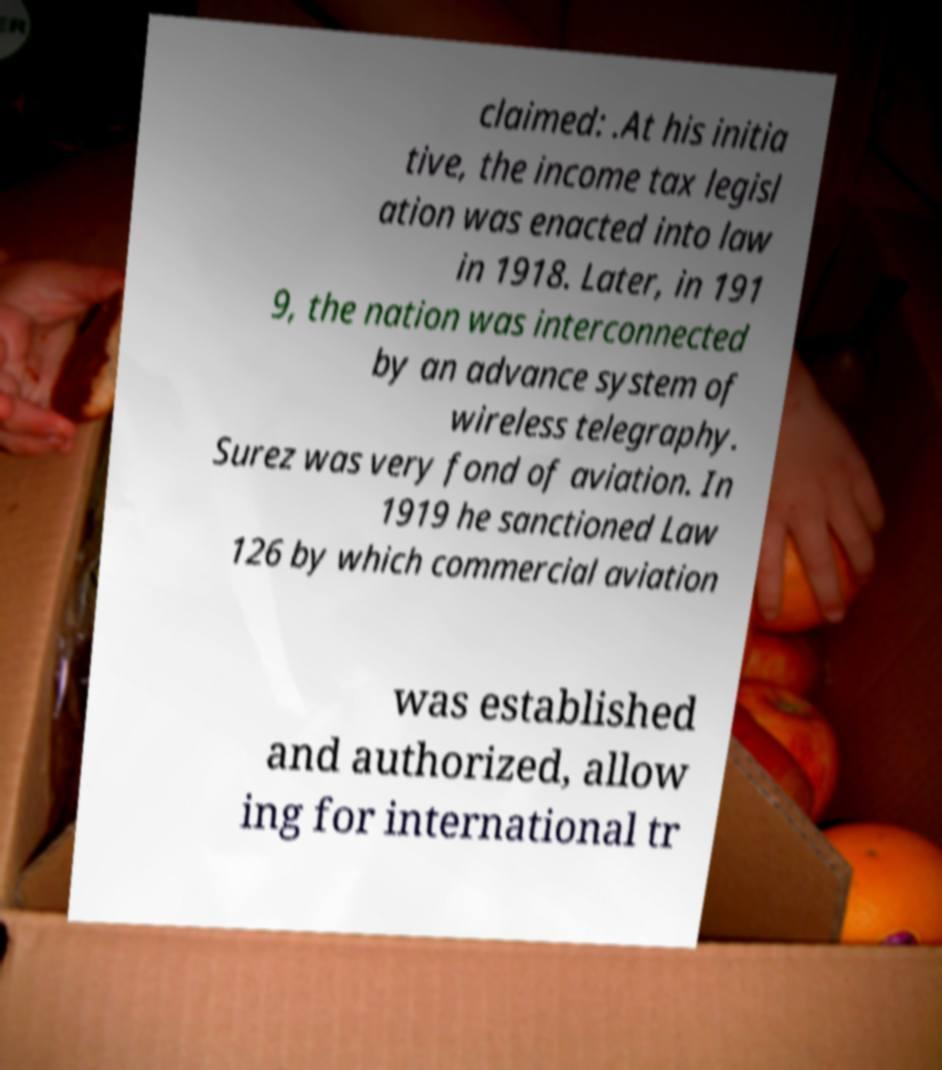There's text embedded in this image that I need extracted. Can you transcribe it verbatim? claimed: .At his initia tive, the income tax legisl ation was enacted into law in 1918. Later, in 191 9, the nation was interconnected by an advance system of wireless telegraphy. Surez was very fond of aviation. In 1919 he sanctioned Law 126 by which commercial aviation was established and authorized, allow ing for international tr 